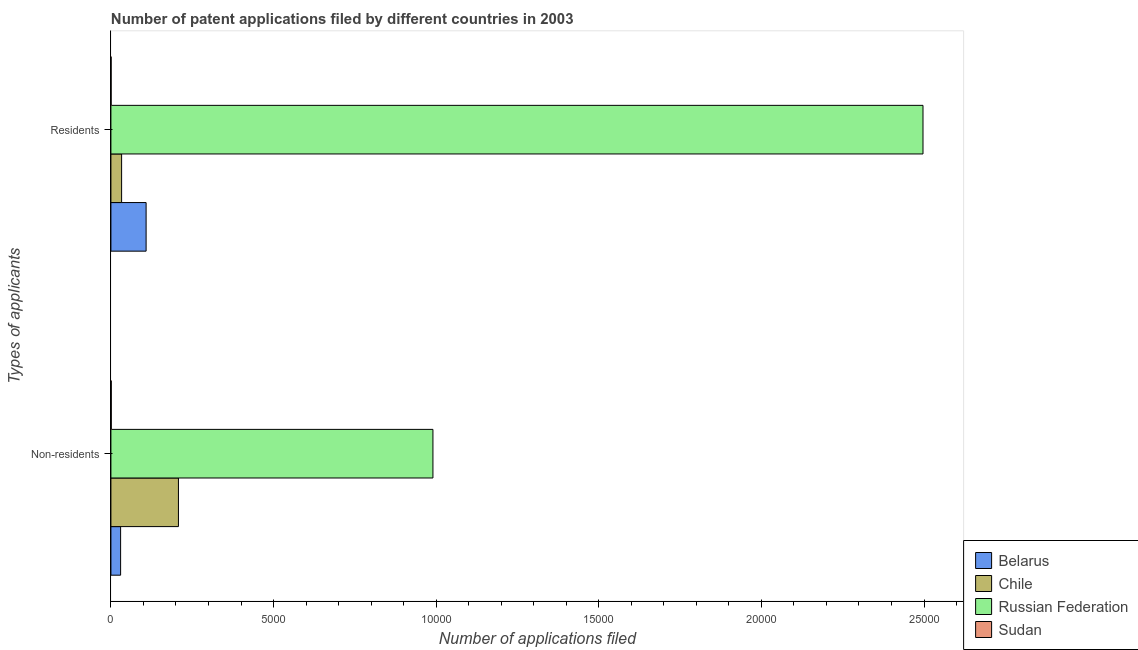How many different coloured bars are there?
Provide a succinct answer. 4. Are the number of bars per tick equal to the number of legend labels?
Offer a very short reply. Yes. What is the label of the 2nd group of bars from the top?
Offer a terse response. Non-residents. What is the number of patent applications by non residents in Russian Federation?
Offer a terse response. 9901. Across all countries, what is the maximum number of patent applications by residents?
Ensure brevity in your answer.  2.50e+04. Across all countries, what is the minimum number of patent applications by non residents?
Your answer should be compact. 11. In which country was the number of patent applications by non residents maximum?
Give a very brief answer. Russian Federation. In which country was the number of patent applications by non residents minimum?
Ensure brevity in your answer.  Sudan. What is the total number of patent applications by residents in the graph?
Your answer should be very brief. 2.64e+04. What is the difference between the number of patent applications by residents in Chile and that in Russian Federation?
Your answer should be very brief. -2.46e+04. What is the difference between the number of patent applications by non residents in Belarus and the number of patent applications by residents in Russian Federation?
Make the answer very short. -2.47e+04. What is the average number of patent applications by residents per country?
Provide a succinct answer. 6596.5. What is the difference between the number of patent applications by residents and number of patent applications by non residents in Chile?
Offer a terse response. -1747. What is the ratio of the number of patent applications by residents in Sudan to that in Russian Federation?
Your answer should be compact. 0. In how many countries, is the number of patent applications by residents greater than the average number of patent applications by residents taken over all countries?
Keep it short and to the point. 1. What does the 4th bar from the top in Residents represents?
Keep it short and to the point. Belarus. What does the 1st bar from the bottom in Residents represents?
Your response must be concise. Belarus. How many bars are there?
Keep it short and to the point. 8. Are all the bars in the graph horizontal?
Your response must be concise. Yes. How many countries are there in the graph?
Give a very brief answer. 4. Does the graph contain any zero values?
Offer a very short reply. No. Does the graph contain grids?
Keep it short and to the point. No. Where does the legend appear in the graph?
Provide a short and direct response. Bottom right. What is the title of the graph?
Ensure brevity in your answer.  Number of patent applications filed by different countries in 2003. What is the label or title of the X-axis?
Your response must be concise. Number of applications filed. What is the label or title of the Y-axis?
Your response must be concise. Types of applicants. What is the Number of applications filed in Belarus in Non-residents?
Your response must be concise. 298. What is the Number of applications filed of Chile in Non-residents?
Your response must be concise. 2076. What is the Number of applications filed of Russian Federation in Non-residents?
Your response must be concise. 9901. What is the Number of applications filed in Belarus in Residents?
Make the answer very short. 1082. What is the Number of applications filed of Chile in Residents?
Keep it short and to the point. 329. What is the Number of applications filed in Russian Federation in Residents?
Keep it short and to the point. 2.50e+04. Across all Types of applicants, what is the maximum Number of applications filed in Belarus?
Offer a very short reply. 1082. Across all Types of applicants, what is the maximum Number of applications filed in Chile?
Your answer should be very brief. 2076. Across all Types of applicants, what is the maximum Number of applications filed in Russian Federation?
Your answer should be compact. 2.50e+04. Across all Types of applicants, what is the minimum Number of applications filed of Belarus?
Your answer should be compact. 298. Across all Types of applicants, what is the minimum Number of applications filed of Chile?
Make the answer very short. 329. Across all Types of applicants, what is the minimum Number of applications filed in Russian Federation?
Provide a short and direct response. 9901. What is the total Number of applications filed in Belarus in the graph?
Offer a very short reply. 1380. What is the total Number of applications filed of Chile in the graph?
Offer a very short reply. 2405. What is the total Number of applications filed of Russian Federation in the graph?
Make the answer very short. 3.49e+04. What is the total Number of applications filed in Sudan in the graph?
Provide a succinct answer. 17. What is the difference between the Number of applications filed of Belarus in Non-residents and that in Residents?
Keep it short and to the point. -784. What is the difference between the Number of applications filed in Chile in Non-residents and that in Residents?
Give a very brief answer. 1747. What is the difference between the Number of applications filed in Russian Federation in Non-residents and that in Residents?
Make the answer very short. -1.51e+04. What is the difference between the Number of applications filed in Belarus in Non-residents and the Number of applications filed in Chile in Residents?
Provide a succinct answer. -31. What is the difference between the Number of applications filed of Belarus in Non-residents and the Number of applications filed of Russian Federation in Residents?
Keep it short and to the point. -2.47e+04. What is the difference between the Number of applications filed of Belarus in Non-residents and the Number of applications filed of Sudan in Residents?
Keep it short and to the point. 292. What is the difference between the Number of applications filed of Chile in Non-residents and the Number of applications filed of Russian Federation in Residents?
Provide a short and direct response. -2.29e+04. What is the difference between the Number of applications filed in Chile in Non-residents and the Number of applications filed in Sudan in Residents?
Provide a succinct answer. 2070. What is the difference between the Number of applications filed in Russian Federation in Non-residents and the Number of applications filed in Sudan in Residents?
Ensure brevity in your answer.  9895. What is the average Number of applications filed in Belarus per Types of applicants?
Provide a short and direct response. 690. What is the average Number of applications filed in Chile per Types of applicants?
Give a very brief answer. 1202.5. What is the average Number of applications filed in Russian Federation per Types of applicants?
Make the answer very short. 1.74e+04. What is the average Number of applications filed of Sudan per Types of applicants?
Ensure brevity in your answer.  8.5. What is the difference between the Number of applications filed of Belarus and Number of applications filed of Chile in Non-residents?
Your answer should be very brief. -1778. What is the difference between the Number of applications filed in Belarus and Number of applications filed in Russian Federation in Non-residents?
Offer a terse response. -9603. What is the difference between the Number of applications filed of Belarus and Number of applications filed of Sudan in Non-residents?
Your response must be concise. 287. What is the difference between the Number of applications filed in Chile and Number of applications filed in Russian Federation in Non-residents?
Ensure brevity in your answer.  -7825. What is the difference between the Number of applications filed of Chile and Number of applications filed of Sudan in Non-residents?
Keep it short and to the point. 2065. What is the difference between the Number of applications filed in Russian Federation and Number of applications filed in Sudan in Non-residents?
Your answer should be compact. 9890. What is the difference between the Number of applications filed in Belarus and Number of applications filed in Chile in Residents?
Offer a terse response. 753. What is the difference between the Number of applications filed in Belarus and Number of applications filed in Russian Federation in Residents?
Offer a terse response. -2.39e+04. What is the difference between the Number of applications filed of Belarus and Number of applications filed of Sudan in Residents?
Make the answer very short. 1076. What is the difference between the Number of applications filed of Chile and Number of applications filed of Russian Federation in Residents?
Offer a very short reply. -2.46e+04. What is the difference between the Number of applications filed of Chile and Number of applications filed of Sudan in Residents?
Provide a short and direct response. 323. What is the difference between the Number of applications filed in Russian Federation and Number of applications filed in Sudan in Residents?
Your answer should be compact. 2.50e+04. What is the ratio of the Number of applications filed of Belarus in Non-residents to that in Residents?
Ensure brevity in your answer.  0.28. What is the ratio of the Number of applications filed of Chile in Non-residents to that in Residents?
Offer a terse response. 6.31. What is the ratio of the Number of applications filed in Russian Federation in Non-residents to that in Residents?
Make the answer very short. 0.4. What is the ratio of the Number of applications filed of Sudan in Non-residents to that in Residents?
Keep it short and to the point. 1.83. What is the difference between the highest and the second highest Number of applications filed of Belarus?
Provide a short and direct response. 784. What is the difference between the highest and the second highest Number of applications filed in Chile?
Offer a very short reply. 1747. What is the difference between the highest and the second highest Number of applications filed in Russian Federation?
Make the answer very short. 1.51e+04. What is the difference between the highest and the lowest Number of applications filed of Belarus?
Your response must be concise. 784. What is the difference between the highest and the lowest Number of applications filed in Chile?
Offer a very short reply. 1747. What is the difference between the highest and the lowest Number of applications filed of Russian Federation?
Your answer should be very brief. 1.51e+04. 